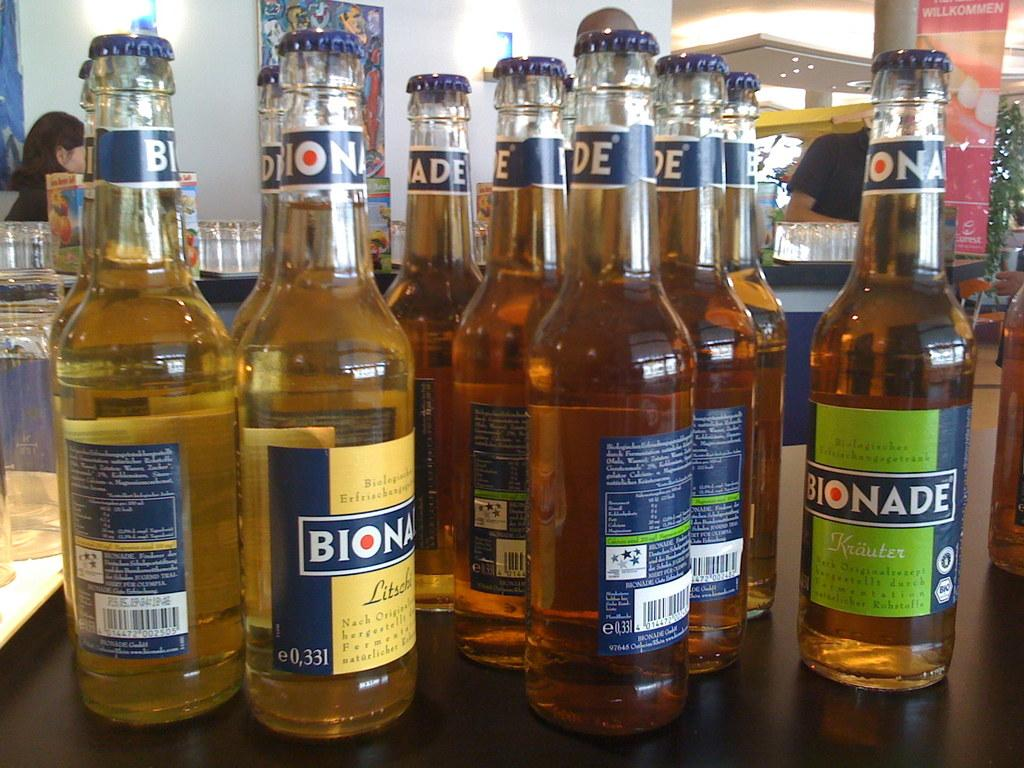<image>
Present a compact description of the photo's key features. Many bottles of Bionade sit on a table. 